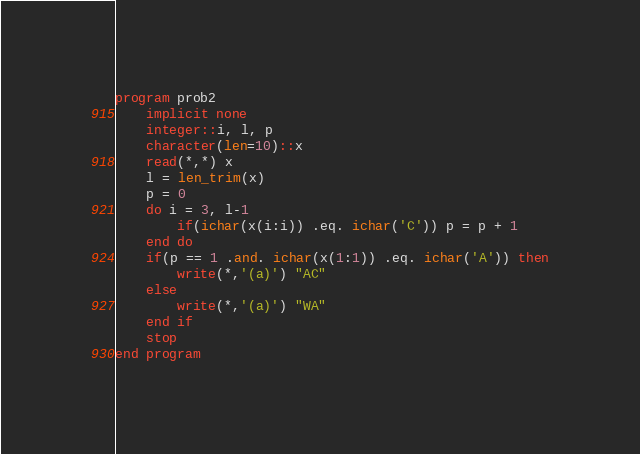<code> <loc_0><loc_0><loc_500><loc_500><_FORTRAN_>program prob2
    implicit none
    integer::i, l, p
    character(len=10)::x
    read(*,*) x
    l = len_trim(x)
    p = 0
    do i = 3, l-1
        if(ichar(x(i:i)) .eq. ichar('C')) p = p + 1
    end do
    if(p == 1 .and. ichar(x(1:1)) .eq. ichar('A')) then
        write(*,'(a)') "AC"
    else
        write(*,'(a)') "WA"
    end if
    stop
end program</code> 